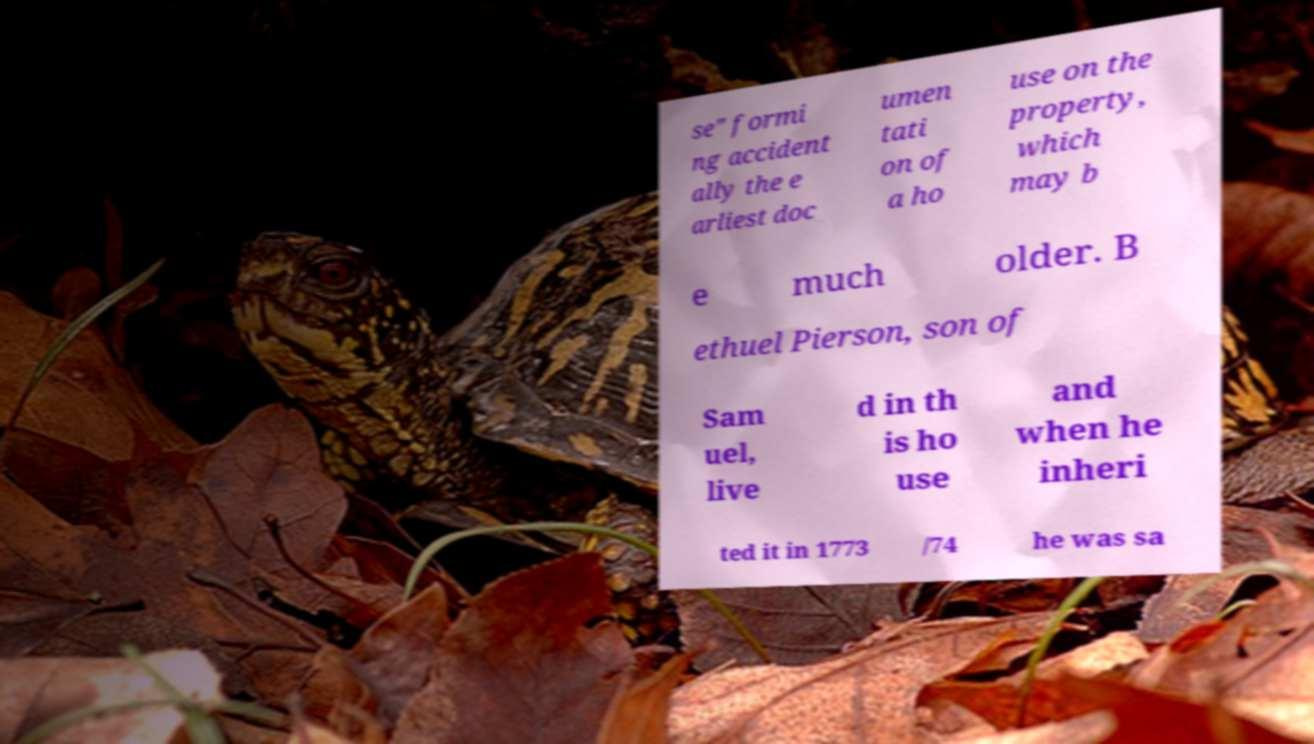For documentation purposes, I need the text within this image transcribed. Could you provide that? se" formi ng accident ally the e arliest doc umen tati on of a ho use on the property, which may b e much older. B ethuel Pierson, son of Sam uel, live d in th is ho use and when he inheri ted it in 1773 /74 he was sa 